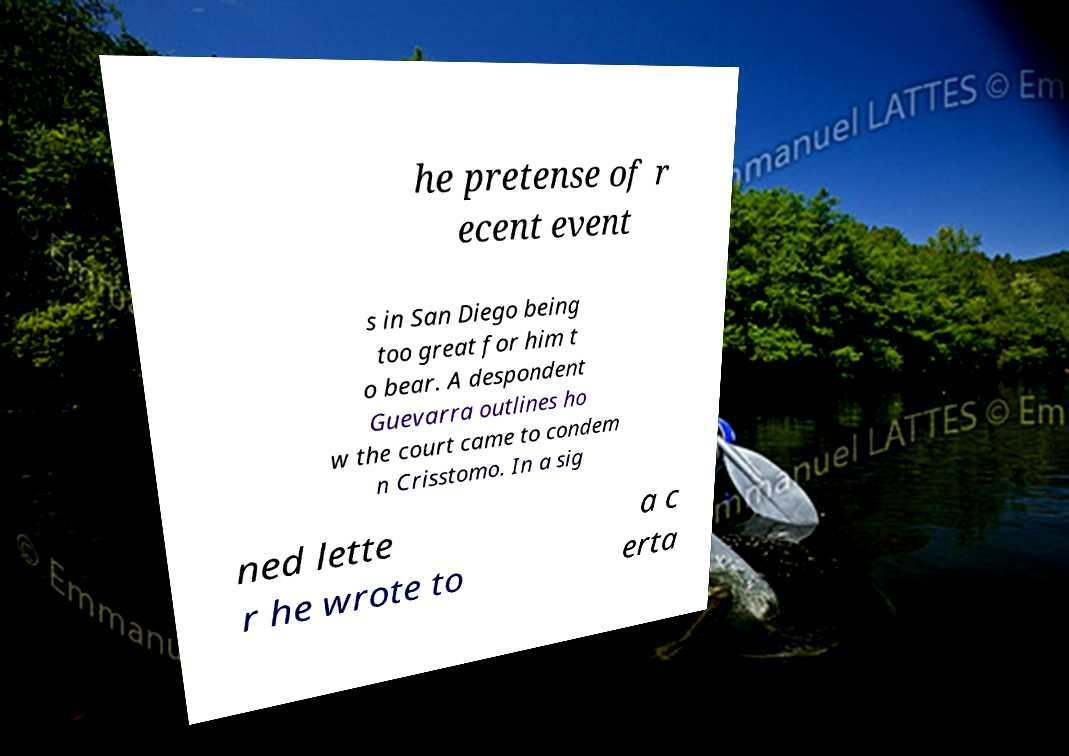Can you read and provide the text displayed in the image?This photo seems to have some interesting text. Can you extract and type it out for me? he pretense of r ecent event s in San Diego being too great for him t o bear. A despondent Guevarra outlines ho w the court came to condem n Crisstomo. In a sig ned lette r he wrote to a c erta 